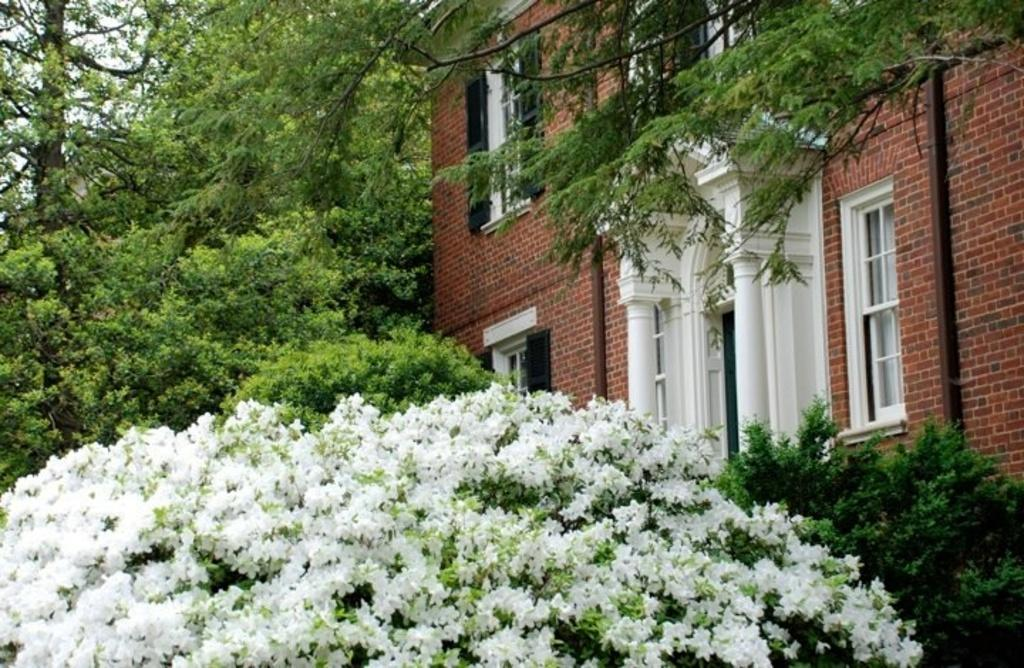What color are the flowers in the image? The flowers in the image are white in color. What can be seen in the background of the image? There is a building in brown color and trees in green color in the background of the image. What is the color of the sky in the image? The sky is white in color. What is the rate at which the faucet is dripping in the image? There is no faucet present in the image, so it is not possible to determine the rate at which it might be dripping. 